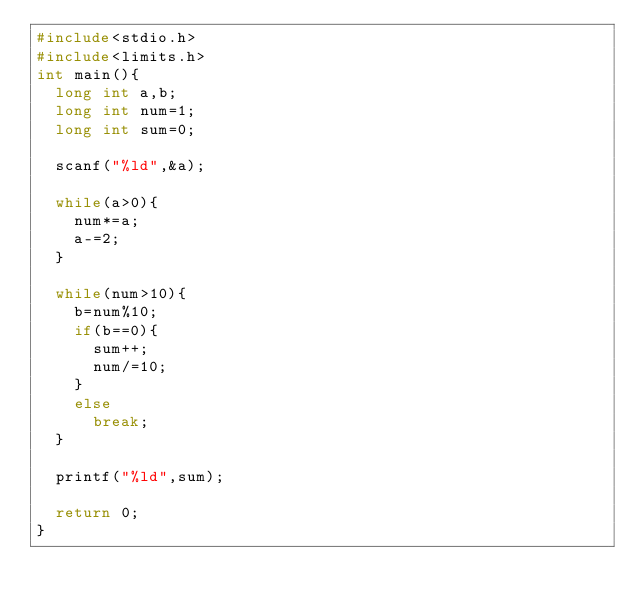<code> <loc_0><loc_0><loc_500><loc_500><_C_>#include<stdio.h>
#include<limits.h>
int main(){
  long int a,b;
  long int num=1;
  long int sum=0;
  
  scanf("%ld",&a);
  
  while(a>0){
  	num*=a;
    a-=2;
  }
  
  while(num>10){
    b=num%10;
    if(b==0){
      sum++;
      num/=10;
    }
    else
      break;
  }
  
  printf("%ld",sum);
  
  return 0;
}</code> 